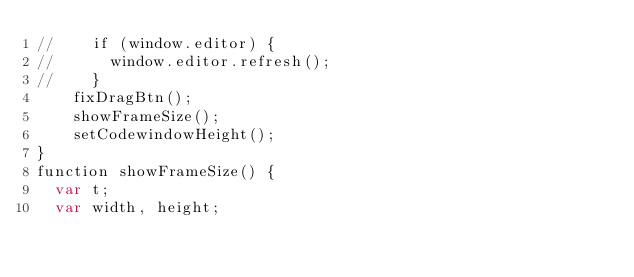Convert code to text. <code><loc_0><loc_0><loc_500><loc_500><_HTML_>//    if (window.editor) {
//      window.editor.refresh();
//    }
    fixDragBtn();
    showFrameSize();
    setCodewindowHeight();
}
function showFrameSize() {
  var t;
  var width, height;</code> 